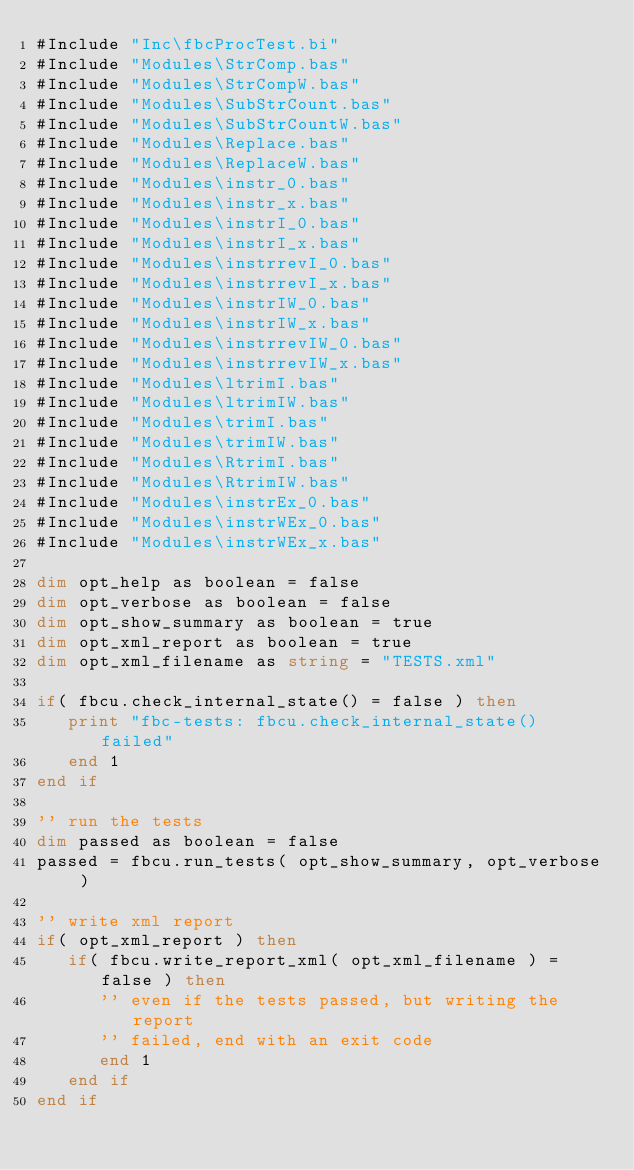Convert code to text. <code><loc_0><loc_0><loc_500><loc_500><_VisualBasic_>#Include "Inc\fbcProcTest.bi"
#Include "Modules\StrComp.bas"
#Include "Modules\StrCompW.bas"
#Include "Modules\SubStrCount.bas"
#Include "Modules\SubStrCountW.bas"
#Include "Modules\Replace.bas"
#Include "Modules\ReplaceW.bas"
#Include "Modules\instr_0.bas"
#Include "Modules\instr_x.bas"
#Include "Modules\instrI_0.bas"
#Include "Modules\instrI_x.bas"
#Include "Modules\instrrevI_0.bas"
#Include "Modules\instrrevI_x.bas"
#Include "Modules\instrIW_0.bas"
#Include "Modules\instrIW_x.bas"
#Include "Modules\instrrevIW_0.bas"
#Include "Modules\instrrevIW_x.bas"
#Include "Modules\ltrimI.bas"
#Include "Modules\ltrimIW.bas"
#Include "Modules\trimI.bas"
#Include "Modules\trimIW.bas"
#Include "Modules\RtrimI.bas"
#Include "Modules\RtrimIW.bas"
#Include "Modules\instrEx_0.bas"
#Include "Modules\instrWEx_0.bas"
#Include "Modules\instrWEx_x.bas"

dim opt_help as boolean = false
dim opt_verbose as boolean = false
dim opt_show_summary as boolean = true
dim opt_xml_report as boolean = true
dim opt_xml_filename as string = "TESTS.xml"

if( fbcu.check_internal_state() = false ) then
   print "fbc-tests: fbcu.check_internal_state() failed"
   end 1
end if

'' run the tests
dim passed as boolean = false
passed = fbcu.run_tests( opt_show_summary, opt_verbose )

'' write xml report
if( opt_xml_report ) then
   if( fbcu.write_report_xml( opt_xml_filename ) = false ) then
      '' even if the tests passed, but writing the report
      '' failed, end with an exit code
      end 1
   end if
end if

</code> 